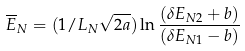Convert formula to latex. <formula><loc_0><loc_0><loc_500><loc_500>\overline { E } _ { N } = ( 1 / L _ { N } \sqrt { 2 a } ) \ln \frac { ( \delta E _ { N 2 } + b ) } { ( \delta E _ { N 1 } - b ) }</formula> 